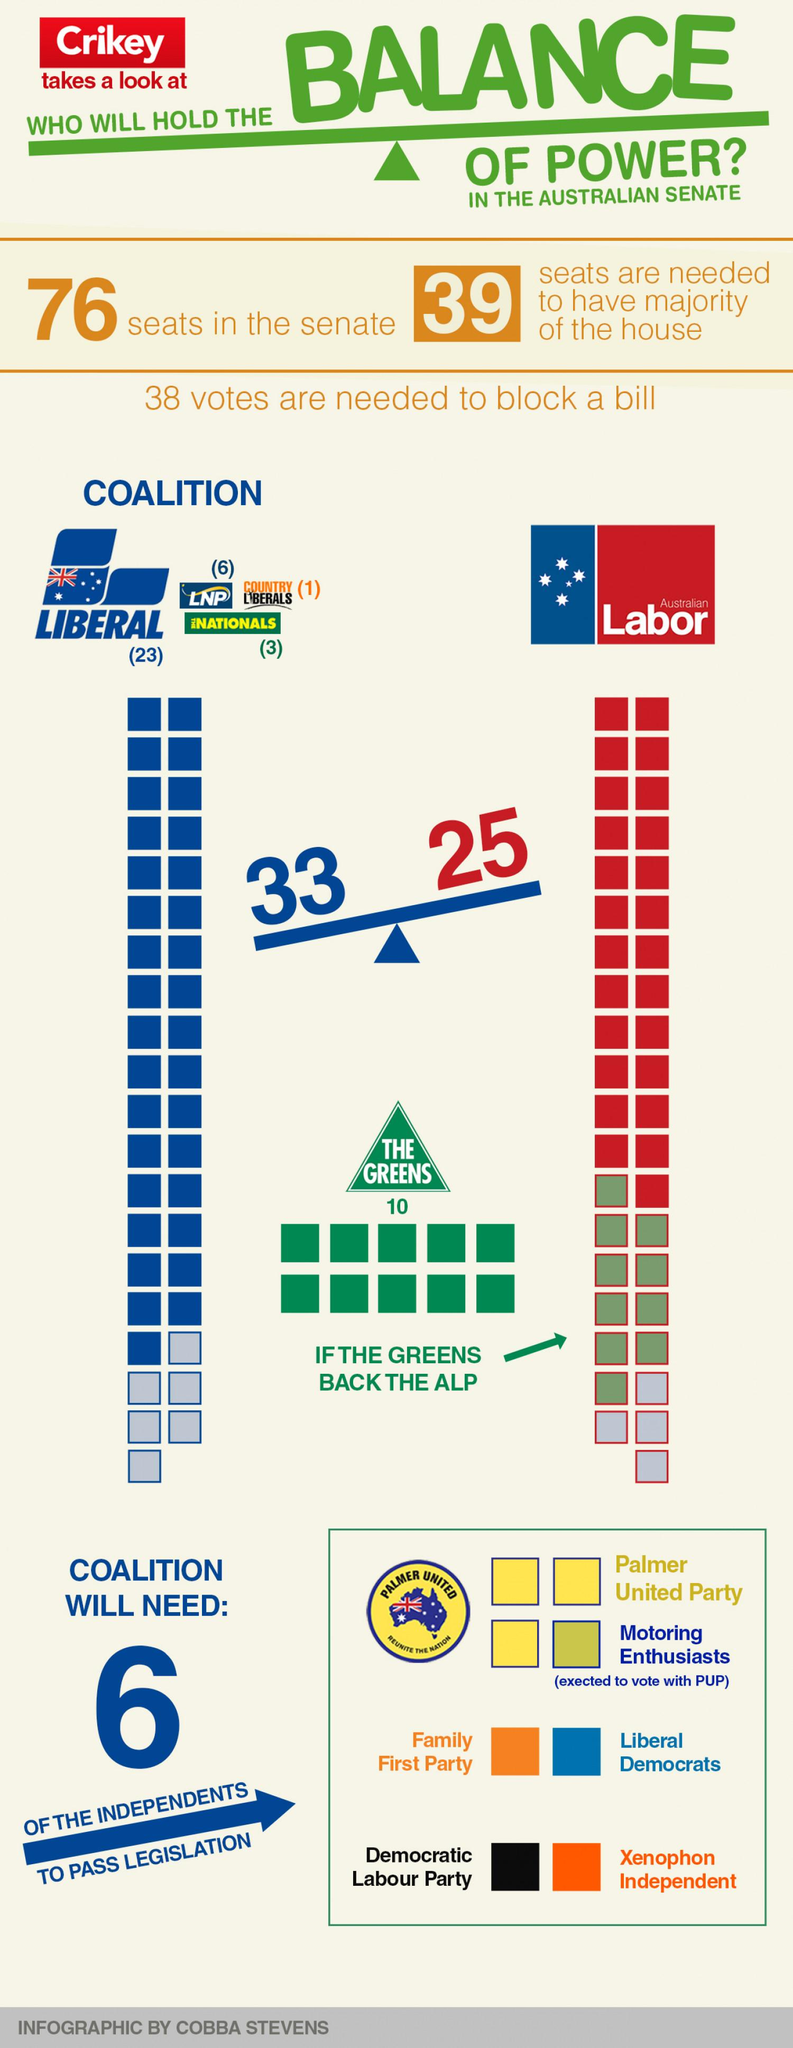Draw attention to some important aspects in this diagram. The Australian Labor Party won 25 seats in the most recent election. The Liberal party received 23 seats in the most recent election. The Liberal party holds the majority of seats in the coalition. The Australian Labor Party is likely to receive support from the Greens. The coalition won 33 seats in the election. 